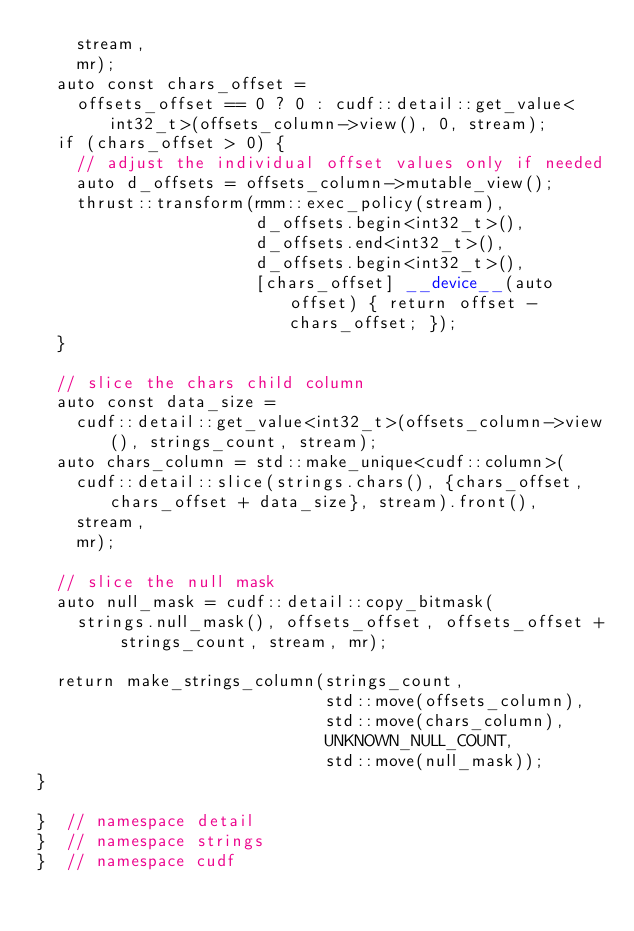<code> <loc_0><loc_0><loc_500><loc_500><_Cuda_>    stream,
    mr);
  auto const chars_offset =
    offsets_offset == 0 ? 0 : cudf::detail::get_value<int32_t>(offsets_column->view(), 0, stream);
  if (chars_offset > 0) {
    // adjust the individual offset values only if needed
    auto d_offsets = offsets_column->mutable_view();
    thrust::transform(rmm::exec_policy(stream),
                      d_offsets.begin<int32_t>(),
                      d_offsets.end<int32_t>(),
                      d_offsets.begin<int32_t>(),
                      [chars_offset] __device__(auto offset) { return offset - chars_offset; });
  }

  // slice the chars child column
  auto const data_size =
    cudf::detail::get_value<int32_t>(offsets_column->view(), strings_count, stream);
  auto chars_column = std::make_unique<cudf::column>(
    cudf::detail::slice(strings.chars(), {chars_offset, chars_offset + data_size}, stream).front(),
    stream,
    mr);

  // slice the null mask
  auto null_mask = cudf::detail::copy_bitmask(
    strings.null_mask(), offsets_offset, offsets_offset + strings_count, stream, mr);

  return make_strings_column(strings_count,
                             std::move(offsets_column),
                             std::move(chars_column),
                             UNKNOWN_NULL_COUNT,
                             std::move(null_mask));
}

}  // namespace detail
}  // namespace strings
}  // namespace cudf
</code> 